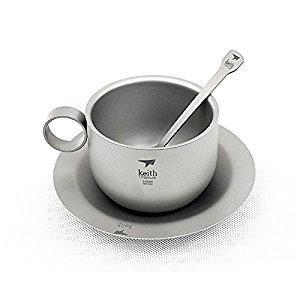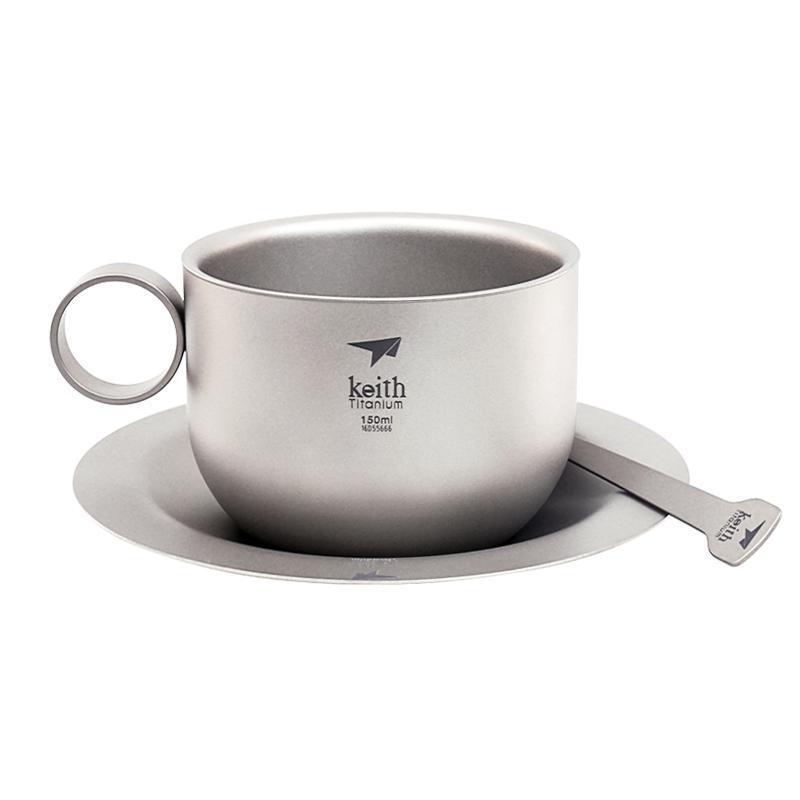The first image is the image on the left, the second image is the image on the right. For the images shown, is this caption "In one image, there is no spoon laid next to the cup on the plate." true? Answer yes or no. Yes. The first image is the image on the left, the second image is the image on the right. Assess this claim about the two images: "Full cups of coffee sit on matching saucers with a spoon.". Correct or not? Answer yes or no. No. 